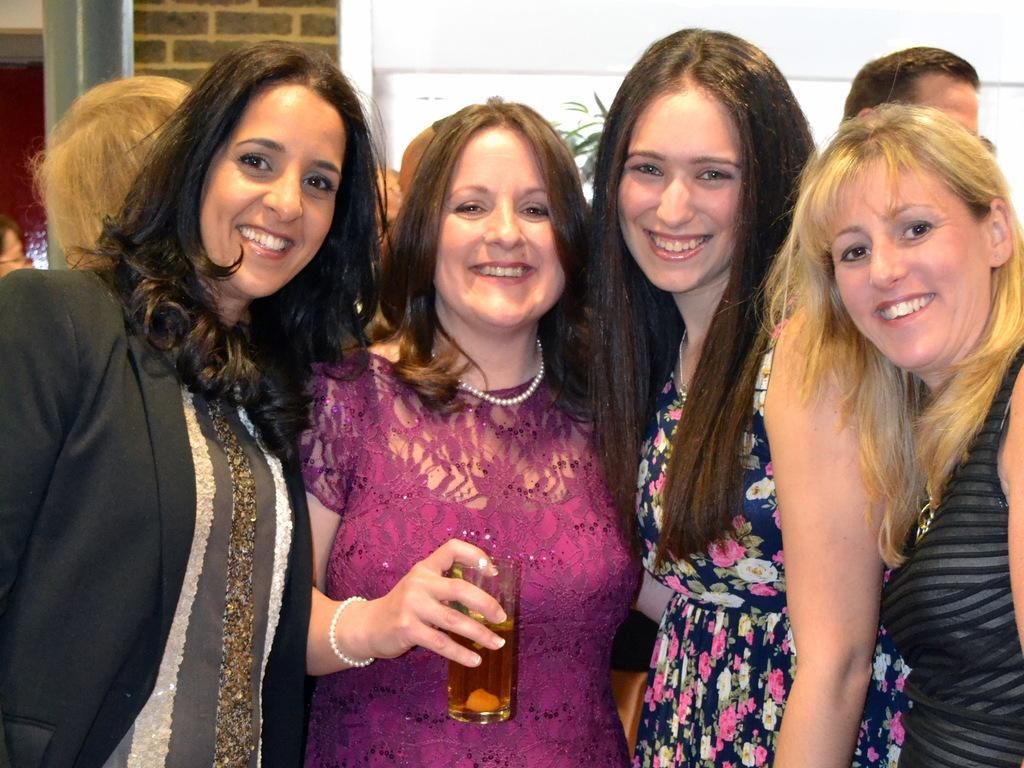Could you give a brief overview of what you see in this image? There are four women standing and smiling. This woman is holding a glass. In the background, I can see few people standing. This looks like a pillar. I think this is the wall. 